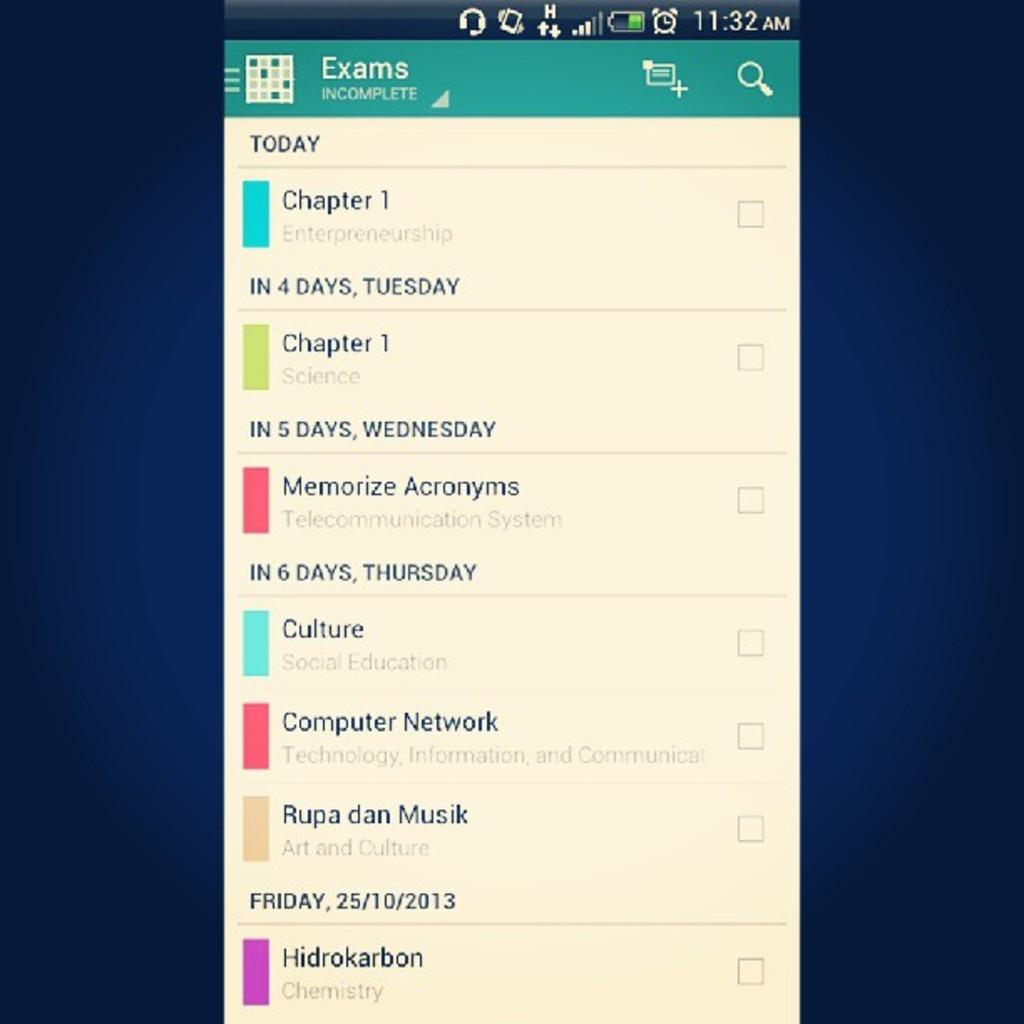<image>
Write a terse but informative summary of the picture. A list of incomplete exams via a smartphone app to be taken this week. 